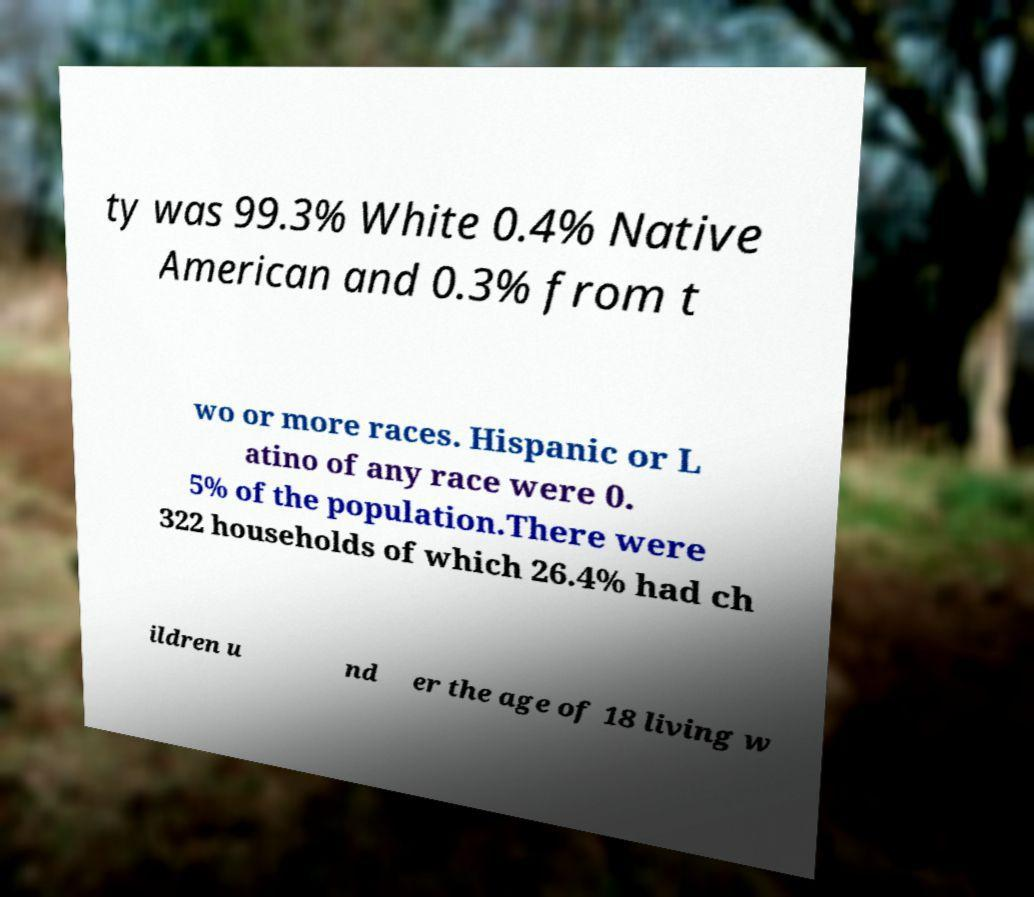Please read and relay the text visible in this image. What does it say? ty was 99.3% White 0.4% Native American and 0.3% from t wo or more races. Hispanic or L atino of any race were 0. 5% of the population.There were 322 households of which 26.4% had ch ildren u nd er the age of 18 living w 